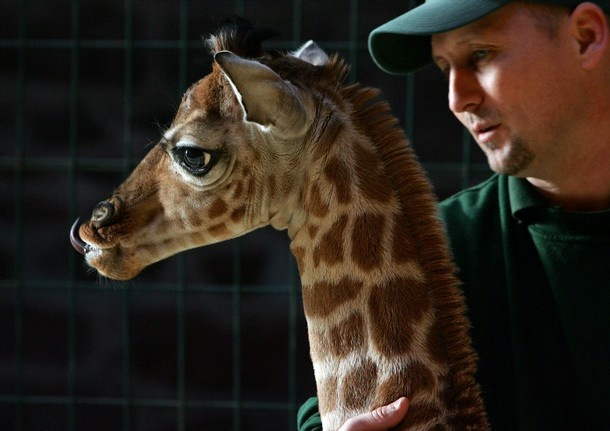Describe the objects in this image and their specific colors. I can see giraffe in black, maroon, and gray tones and people in black, maroon, brown, and gray tones in this image. 